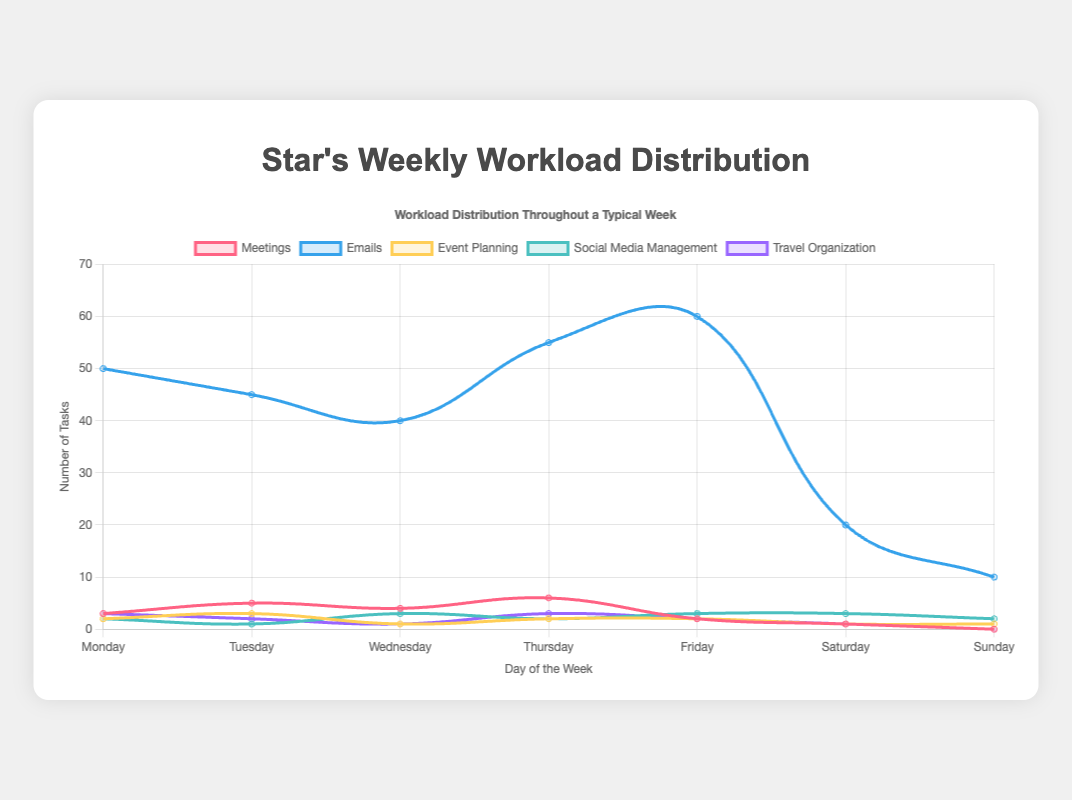What day has the highest number of emails sent? By looking at the "Emails" dataset, the highest value is 60, which corresponds to Friday.
Answer: Friday Compare the number of meetings on Monday and Thursday. Which day has more meetings? Referring to the "Meetings" dataset, Monday has 3 meetings, and Thursday has 6 meetings. Thus, Thursday has more meetings.
Answer: Thursday Which task has the most significant variation in numbers throughout the week? Observing the entire dataset, the "Emails" task has the highest variation in values, ranging from 10 to 60.
Answer: Emails On which day is the workload for "Social Media Management" the highest, and what is the corresponding value? By looking at the "Social Media Management" dataset, the highest values, 3, occur on Wednesday, Friday, and Saturday.
Answer: Wednesday, Friday, Saturday with values of 3 How many total meetings are held from Monday to Friday? Sum the values from the "Meetings" dataset for Monday (3), Tuesday (5), Wednesday (4), Thursday (6), and Friday (2). The total is 3 + 5 + 4 + 6 + 2 = 20.
Answer: 20 Is there a day when no travel organization tasks were scheduled? If so, which day? Observing the "Travel Organization" dataset, the value is 0 for Sunday.
Answer: Sunday Compare the number of emails sent on Tuesday and Wednesday. How many more or fewer emails were sent on Tuesday compared to Wednesday? The "Emails" dataset shows Tuesday with 45 emails and Wednesday with 40 emails. The difference is 45 - 40 = 5 more emails on Tuesday.
Answer: 5 more emails on Tuesday What is the average number of event planning tasks from Monday to Sunday? Sum the values from the "Event Planning" dataset: 2 + 3 + 1 + 2 + 2 + 1 + 1 = 12. There are 7 days in total, so the average is 12 / 7 = 1.71 (rounded to two decimal places).
Answer: 1.71 If we sum up all the tasks for each day in a week, which day has the highest total workload? By computing the total workload from the above sums, Friday has the highest total workload with 69 tasks.
Answer: Friday 